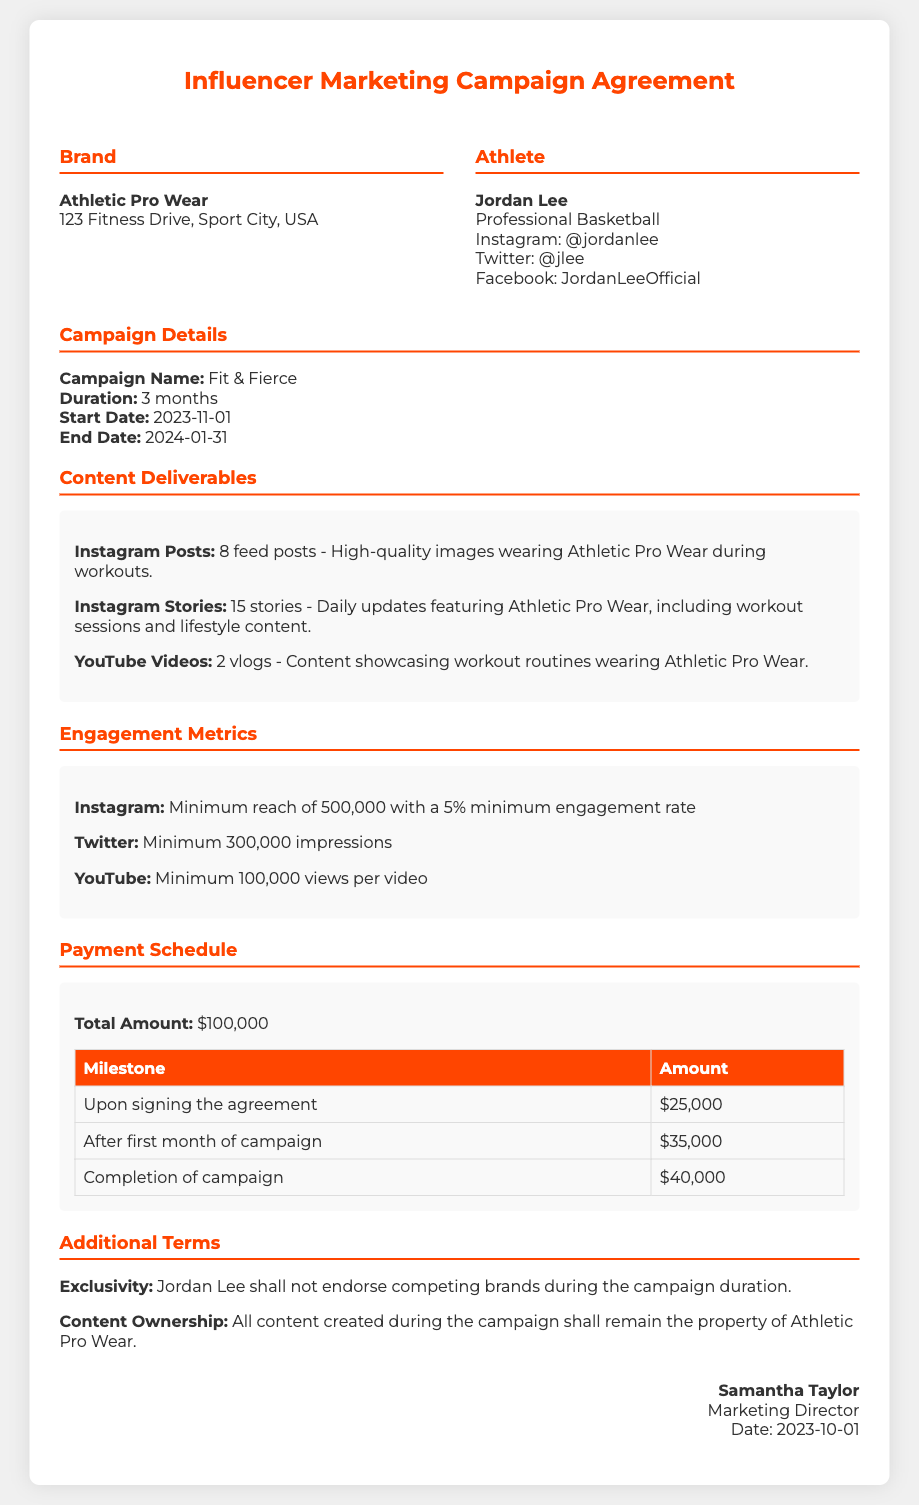What is the name of the campaign? The campaign name is stated in the document under campaign details.
Answer: Fit & Fierce What is the total amount to be paid? The total payment amount is detailed in the payment schedule section.
Answer: $100,000 How many Instagram feed posts are required? The required number of Instagram posts is specified in the content deliverables section.
Answer: 8 feed posts What is the minimum engagement rate for Instagram? The minimum engagement rate is mentioned in the engagement metrics section of the document.
Answer: 5% Who is the Marketing Director? The name of the Marketing Director is listed at the end of the document in the signature section.
Answer: Samantha Taylor What is the start date of the campaign? The start date is found under the campaign details section of the document.
Answer: 2023-11-01 What is one of the additional terms mentioned? Additional terms include exclusivity and content ownership, which can be referenced in their respective sections.
Answer: Exclusivity How much will be paid upon signing the agreement? The amount for the initial payment is found in the payment schedule table.
Answer: $25,000 What is the duration of the campaign? The duration is noted under the campaign details section.
Answer: 3 months 